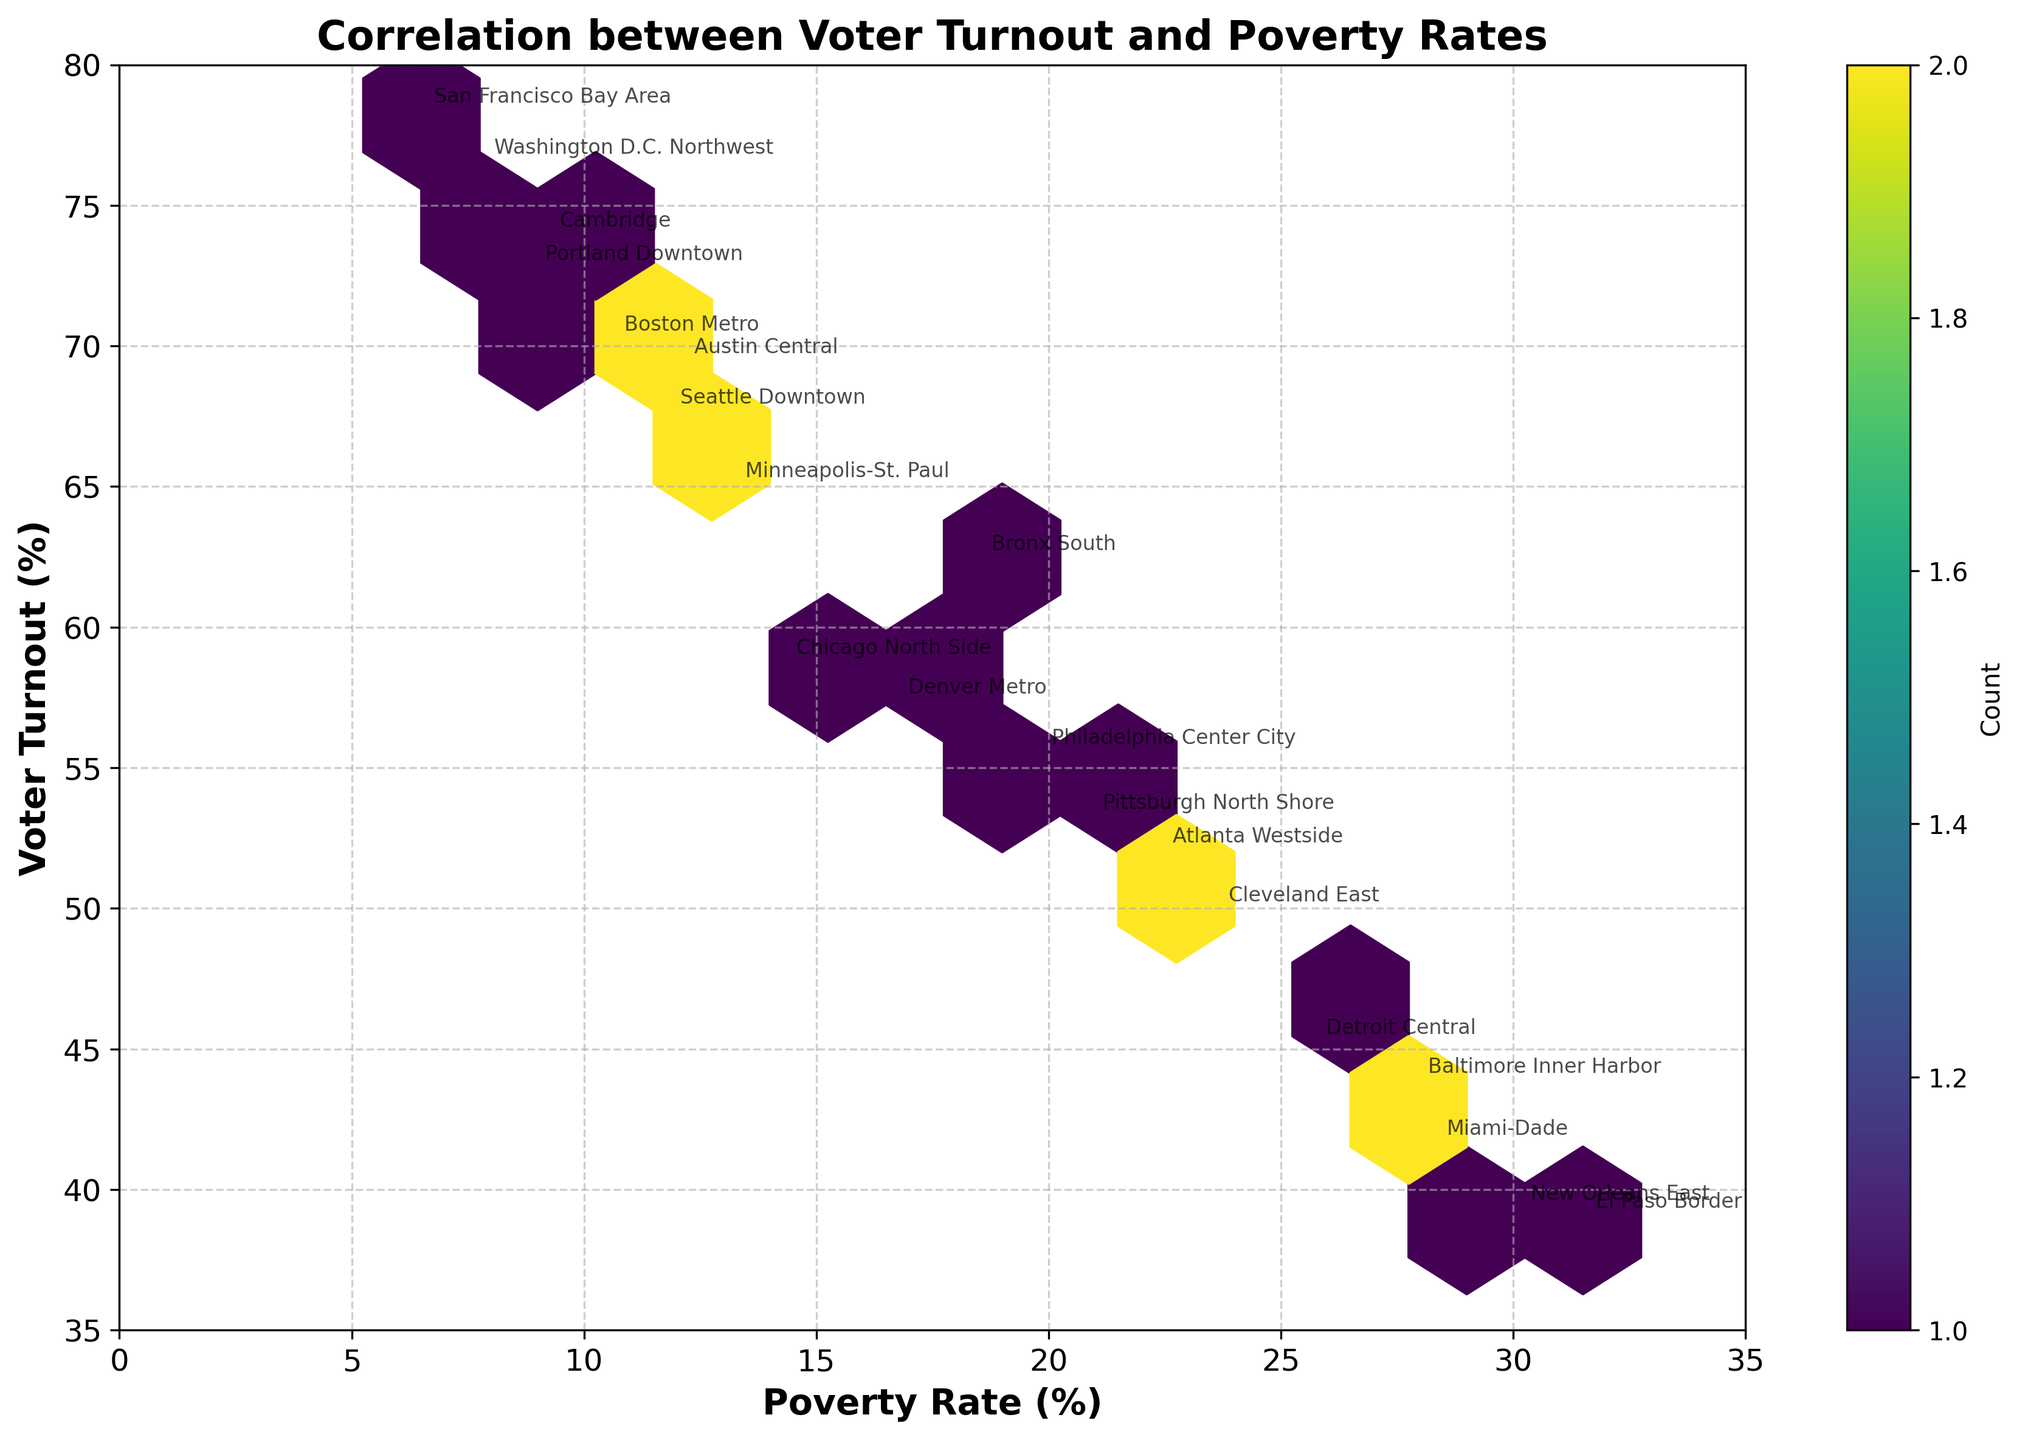What is the title of the figure? The title is displayed at the top of the figure, typically in a larger and bold font. In this case, it reads "Correlation between Voter Turnout and Poverty Rates."
Answer: Correlation between Voter Turnout and Poverty Rates What does the color in the hexagons represent? The color of the hexagons represents the data density. A color bar on the right side of the figure shows the color gradient, which indicates the density of data points in each hexagon.
Answer: Data density What pattern can be observed between voter turnout and poverty rates? Looking at the hexagons' distribution, there appears to be a trend where higher voter turnouts are associated with lower poverty rates, as denser regions of the plot are located in the bottom-left to top-right diagonal.
Answer: Higher turnout, lower poverty What is the approximate range of voter turnout percentages shown on the y-axis? The y-axis, labeled "Voter Turnout (%)," ranges from about 35% to 80%.
Answer: 35% to 80% Which electoral district has the highest voter turnout, and what is its turnout percentage? By looking at the annotated data points and finding the one with the highest y-axis value, we can see "San Francisco Bay Area" has the highest voter turnout at approximately 78.2%.
Answer: San Francisco Bay Area, 78.2% Which electoral district has the highest poverty rate, and what is its rate? The district with the highest poverty rate is annotated at the highest x-axis value, "El Paso Border," with a rate of 31.5%.
Answer: El Paso Border, 31.5% What is the color code approximating the highest data density on the plot? Observing the color bar and the figure, the highest data density corresponds to the darkest shade of the 'viridis' color map.
Answer: Darkest shade of 'viridis' Is there any district with both low voter turnout and high poverty rate? If yes, name one. By identifying districts positioned in the bottom-right section of the plot, "El Paso Border" has a low voter turnout (~38.9%) and a high poverty rate (31.5%).
Answer: El Paso Border What is the voter turnout percentage for the district "Detroit Central"? The district names are annotated near their respective data points; "Detroit Central" is positioned around 45.1% on the y-axis.
Answer: 45.1% Which has a higher voter turnout, "Austin Central" or "Denver Metro"? Comparing the y-axis positions of both data points, "Austin Central" (69.3%) is higher than "Denver Metro" (57.2%).
Answer: Austin Central 